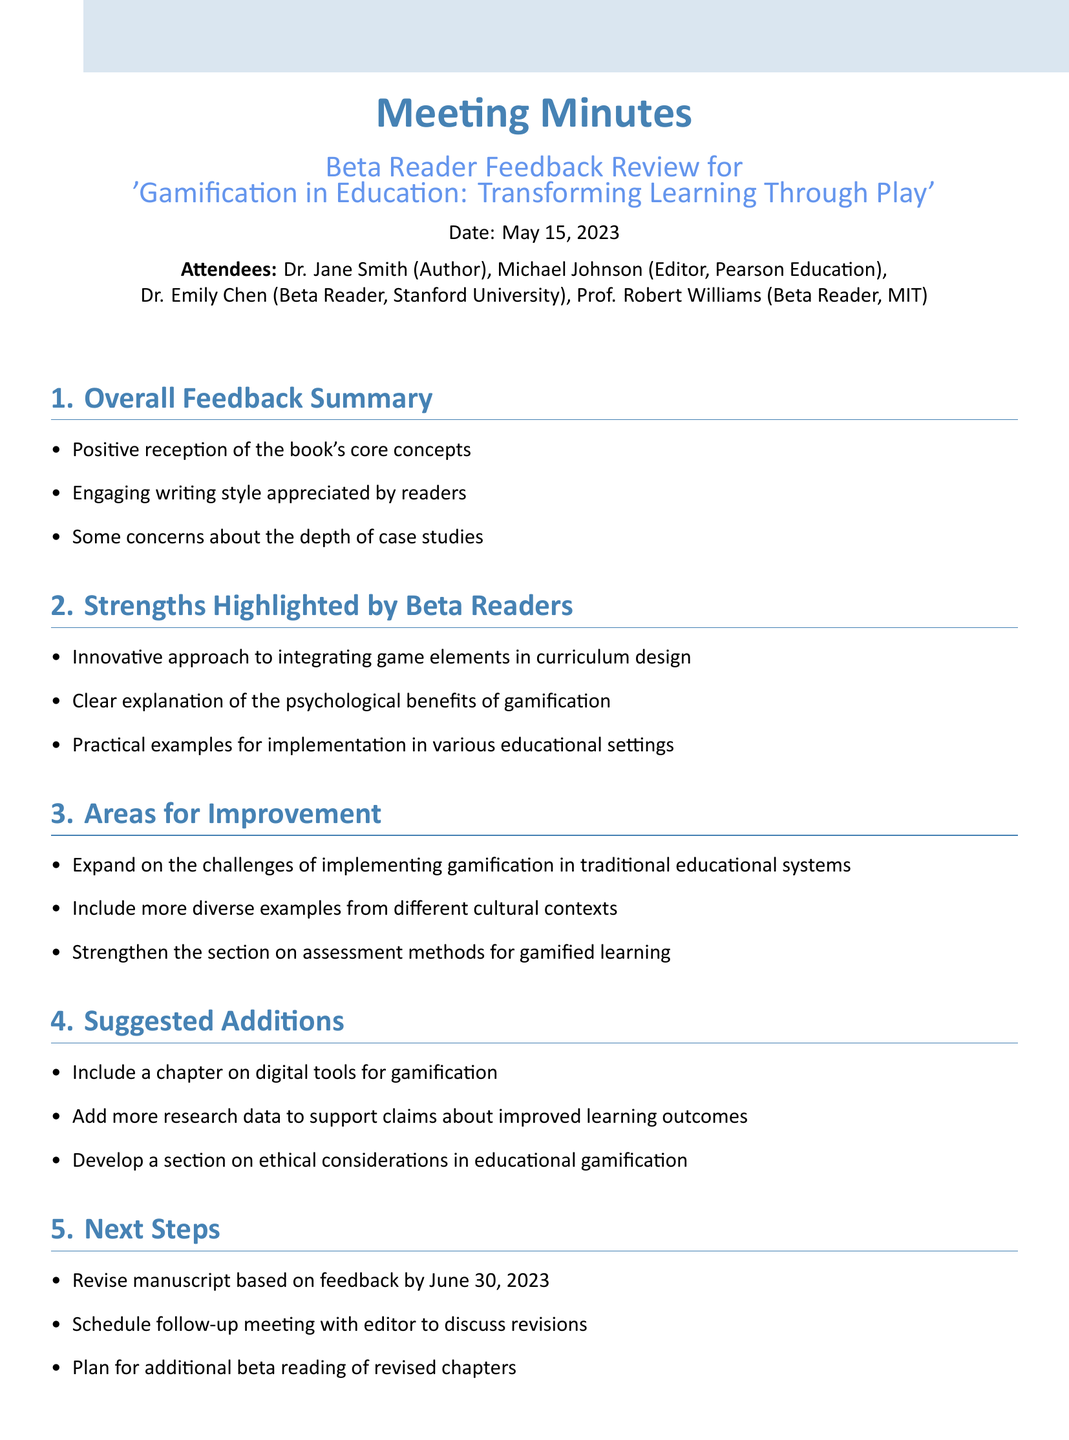What is the title of the book discussed in the meeting? The title of the book is mentioned in the meeting title at the top of the document.
Answer: Gamification in Education: Transforming Learning Through Play Who is the author of the book? The author is listed among the attendees at the beginning of the document.
Answer: Dr. Jane Smith On what date was the meeting held? The meeting date is outlined near the title of the document.
Answer: May 15, 2023 What is a strength highlighted by beta readers? Strengths are listed in the second agenda item of the meeting minutes.
Answer: Innovative approach to integrating game elements in curriculum design What is suggested to be added in the manuscript? The suggestions for additions are clearly specified under the Suggested Additions section.
Answer: Include a chapter on digital tools for gamification What is one area for improvement mentioned? Areas for improvement are listed in the corresponding agenda item.
Answer: Expand on the challenges of implementing gamification in traditional educational systems How many attendees were present at the meeting? The total number of attendees is stated at the beginning of the minutes.
Answer: Four What is the deadline for revising the manuscript based on feedback? The deadline is provided in the Next Steps section of the meeting minutes.
Answer: June 30, 2023 Who is the editor mentioned in the meeting? The editor's name is given in the list of attendees.
Answer: Michael Johnson 